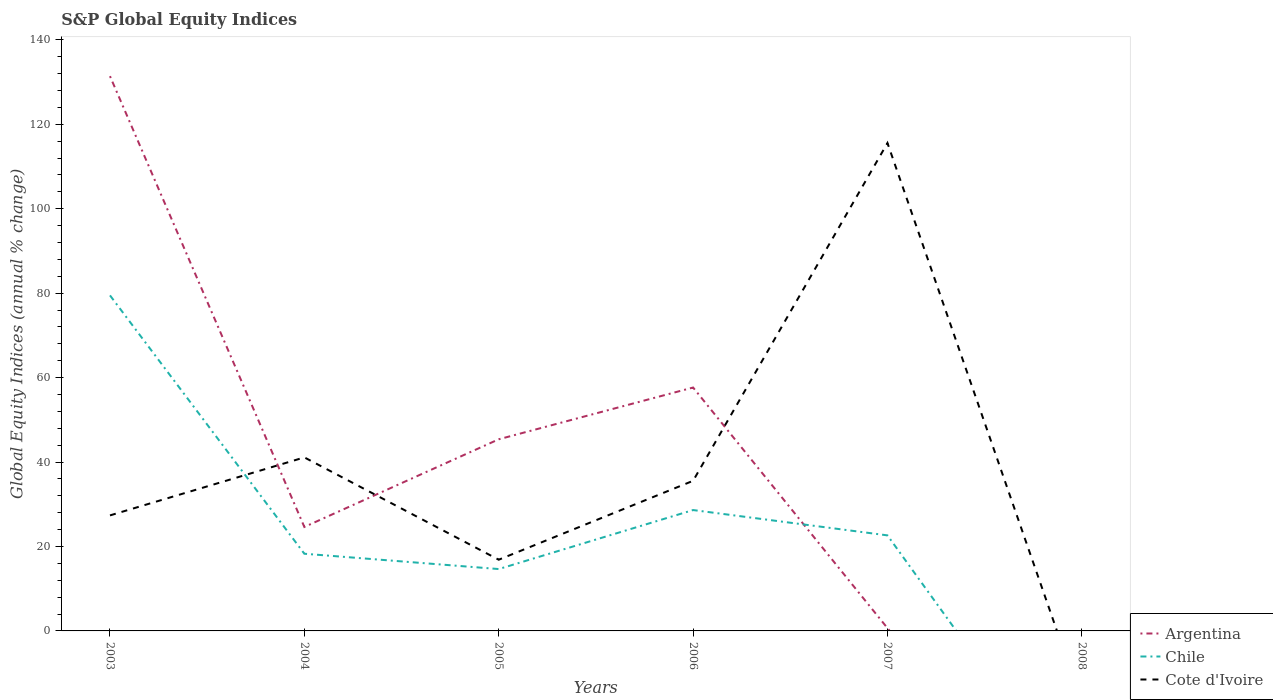What is the total global equity indices in Argentina in the graph?
Give a very brief answer. 23.95. What is the difference between the highest and the second highest global equity indices in Chile?
Provide a succinct answer. 79.47. What is the difference between the highest and the lowest global equity indices in Chile?
Your answer should be compact. 2. How many years are there in the graph?
Your response must be concise. 6. Are the values on the major ticks of Y-axis written in scientific E-notation?
Provide a short and direct response. No. How many legend labels are there?
Make the answer very short. 3. What is the title of the graph?
Offer a very short reply. S&P Global Equity Indices. Does "Sao Tome and Principe" appear as one of the legend labels in the graph?
Your answer should be very brief. No. What is the label or title of the Y-axis?
Your response must be concise. Global Equity Indices (annual % change). What is the Global Equity Indices (annual % change) of Argentina in 2003?
Provide a short and direct response. 131.39. What is the Global Equity Indices (annual % change) of Chile in 2003?
Ensure brevity in your answer.  79.47. What is the Global Equity Indices (annual % change) in Cote d'Ivoire in 2003?
Give a very brief answer. 27.36. What is the Global Equity Indices (annual % change) of Argentina in 2004?
Offer a very short reply. 24.62. What is the Global Equity Indices (annual % change) in Chile in 2004?
Your response must be concise. 18.28. What is the Global Equity Indices (annual % change) of Cote d'Ivoire in 2004?
Keep it short and to the point. 41.1. What is the Global Equity Indices (annual % change) of Argentina in 2005?
Keep it short and to the point. 45.39. What is the Global Equity Indices (annual % change) of Chile in 2005?
Ensure brevity in your answer.  14.65. What is the Global Equity Indices (annual % change) in Cote d'Ivoire in 2005?
Give a very brief answer. 16.87. What is the Global Equity Indices (annual % change) in Argentina in 2006?
Keep it short and to the point. 57.65. What is the Global Equity Indices (annual % change) of Chile in 2006?
Provide a short and direct response. 28.63. What is the Global Equity Indices (annual % change) of Cote d'Ivoire in 2006?
Ensure brevity in your answer.  35.55. What is the Global Equity Indices (annual % change) in Argentina in 2007?
Offer a terse response. 0.67. What is the Global Equity Indices (annual % change) of Chile in 2007?
Your response must be concise. 22.63. What is the Global Equity Indices (annual % change) of Cote d'Ivoire in 2007?
Keep it short and to the point. 115.56. Across all years, what is the maximum Global Equity Indices (annual % change) in Argentina?
Your response must be concise. 131.39. Across all years, what is the maximum Global Equity Indices (annual % change) of Chile?
Keep it short and to the point. 79.47. Across all years, what is the maximum Global Equity Indices (annual % change) in Cote d'Ivoire?
Offer a very short reply. 115.56. Across all years, what is the minimum Global Equity Indices (annual % change) of Chile?
Provide a succinct answer. 0. Across all years, what is the minimum Global Equity Indices (annual % change) in Cote d'Ivoire?
Give a very brief answer. 0. What is the total Global Equity Indices (annual % change) of Argentina in the graph?
Keep it short and to the point. 259.71. What is the total Global Equity Indices (annual % change) in Chile in the graph?
Make the answer very short. 163.66. What is the total Global Equity Indices (annual % change) in Cote d'Ivoire in the graph?
Ensure brevity in your answer.  236.44. What is the difference between the Global Equity Indices (annual % change) in Argentina in 2003 and that in 2004?
Make the answer very short. 106.77. What is the difference between the Global Equity Indices (annual % change) of Chile in 2003 and that in 2004?
Your answer should be very brief. 61.19. What is the difference between the Global Equity Indices (annual % change) of Cote d'Ivoire in 2003 and that in 2004?
Give a very brief answer. -13.74. What is the difference between the Global Equity Indices (annual % change) in Argentina in 2003 and that in 2005?
Make the answer very short. 86. What is the difference between the Global Equity Indices (annual % change) in Chile in 2003 and that in 2005?
Your answer should be compact. 64.82. What is the difference between the Global Equity Indices (annual % change) of Cote d'Ivoire in 2003 and that in 2005?
Your answer should be very brief. 10.49. What is the difference between the Global Equity Indices (annual % change) in Argentina in 2003 and that in 2006?
Give a very brief answer. 73.74. What is the difference between the Global Equity Indices (annual % change) in Chile in 2003 and that in 2006?
Your answer should be compact. 50.84. What is the difference between the Global Equity Indices (annual % change) of Cote d'Ivoire in 2003 and that in 2006?
Keep it short and to the point. -8.19. What is the difference between the Global Equity Indices (annual % change) in Argentina in 2003 and that in 2007?
Your response must be concise. 130.72. What is the difference between the Global Equity Indices (annual % change) of Chile in 2003 and that in 2007?
Provide a succinct answer. 56.84. What is the difference between the Global Equity Indices (annual % change) in Cote d'Ivoire in 2003 and that in 2007?
Offer a very short reply. -88.2. What is the difference between the Global Equity Indices (annual % change) of Argentina in 2004 and that in 2005?
Your response must be concise. -20.77. What is the difference between the Global Equity Indices (annual % change) in Chile in 2004 and that in 2005?
Your answer should be very brief. 3.63. What is the difference between the Global Equity Indices (annual % change) in Cote d'Ivoire in 2004 and that in 2005?
Your response must be concise. 24.23. What is the difference between the Global Equity Indices (annual % change) of Argentina in 2004 and that in 2006?
Your response must be concise. -33.03. What is the difference between the Global Equity Indices (annual % change) in Chile in 2004 and that in 2006?
Offer a very short reply. -10.35. What is the difference between the Global Equity Indices (annual % change) in Cote d'Ivoire in 2004 and that in 2006?
Make the answer very short. 5.55. What is the difference between the Global Equity Indices (annual % change) in Argentina in 2004 and that in 2007?
Offer a terse response. 23.95. What is the difference between the Global Equity Indices (annual % change) in Chile in 2004 and that in 2007?
Make the answer very short. -4.35. What is the difference between the Global Equity Indices (annual % change) in Cote d'Ivoire in 2004 and that in 2007?
Provide a short and direct response. -74.46. What is the difference between the Global Equity Indices (annual % change) of Argentina in 2005 and that in 2006?
Keep it short and to the point. -12.26. What is the difference between the Global Equity Indices (annual % change) of Chile in 2005 and that in 2006?
Make the answer very short. -13.98. What is the difference between the Global Equity Indices (annual % change) in Cote d'Ivoire in 2005 and that in 2006?
Your answer should be compact. -18.69. What is the difference between the Global Equity Indices (annual % change) of Argentina in 2005 and that in 2007?
Make the answer very short. 44.72. What is the difference between the Global Equity Indices (annual % change) of Chile in 2005 and that in 2007?
Provide a succinct answer. -7.98. What is the difference between the Global Equity Indices (annual % change) of Cote d'Ivoire in 2005 and that in 2007?
Provide a short and direct response. -98.69. What is the difference between the Global Equity Indices (annual % change) in Argentina in 2006 and that in 2007?
Provide a short and direct response. 56.98. What is the difference between the Global Equity Indices (annual % change) of Chile in 2006 and that in 2007?
Your answer should be compact. 6. What is the difference between the Global Equity Indices (annual % change) in Cote d'Ivoire in 2006 and that in 2007?
Keep it short and to the point. -80. What is the difference between the Global Equity Indices (annual % change) of Argentina in 2003 and the Global Equity Indices (annual % change) of Chile in 2004?
Ensure brevity in your answer.  113.11. What is the difference between the Global Equity Indices (annual % change) in Argentina in 2003 and the Global Equity Indices (annual % change) in Cote d'Ivoire in 2004?
Your answer should be compact. 90.29. What is the difference between the Global Equity Indices (annual % change) in Chile in 2003 and the Global Equity Indices (annual % change) in Cote d'Ivoire in 2004?
Your response must be concise. 38.37. What is the difference between the Global Equity Indices (annual % change) of Argentina in 2003 and the Global Equity Indices (annual % change) of Chile in 2005?
Ensure brevity in your answer.  116.74. What is the difference between the Global Equity Indices (annual % change) of Argentina in 2003 and the Global Equity Indices (annual % change) of Cote d'Ivoire in 2005?
Your answer should be very brief. 114.52. What is the difference between the Global Equity Indices (annual % change) of Chile in 2003 and the Global Equity Indices (annual % change) of Cote d'Ivoire in 2005?
Provide a short and direct response. 62.6. What is the difference between the Global Equity Indices (annual % change) of Argentina in 2003 and the Global Equity Indices (annual % change) of Chile in 2006?
Your response must be concise. 102.76. What is the difference between the Global Equity Indices (annual % change) in Argentina in 2003 and the Global Equity Indices (annual % change) in Cote d'Ivoire in 2006?
Keep it short and to the point. 95.84. What is the difference between the Global Equity Indices (annual % change) of Chile in 2003 and the Global Equity Indices (annual % change) of Cote d'Ivoire in 2006?
Offer a very short reply. 43.92. What is the difference between the Global Equity Indices (annual % change) of Argentina in 2003 and the Global Equity Indices (annual % change) of Chile in 2007?
Give a very brief answer. 108.76. What is the difference between the Global Equity Indices (annual % change) in Argentina in 2003 and the Global Equity Indices (annual % change) in Cote d'Ivoire in 2007?
Make the answer very short. 15.83. What is the difference between the Global Equity Indices (annual % change) in Chile in 2003 and the Global Equity Indices (annual % change) in Cote d'Ivoire in 2007?
Provide a succinct answer. -36.09. What is the difference between the Global Equity Indices (annual % change) in Argentina in 2004 and the Global Equity Indices (annual % change) in Chile in 2005?
Your answer should be compact. 9.97. What is the difference between the Global Equity Indices (annual % change) of Argentina in 2004 and the Global Equity Indices (annual % change) of Cote d'Ivoire in 2005?
Your answer should be very brief. 7.75. What is the difference between the Global Equity Indices (annual % change) in Chile in 2004 and the Global Equity Indices (annual % change) in Cote d'Ivoire in 2005?
Offer a very short reply. 1.41. What is the difference between the Global Equity Indices (annual % change) of Argentina in 2004 and the Global Equity Indices (annual % change) of Chile in 2006?
Keep it short and to the point. -4.01. What is the difference between the Global Equity Indices (annual % change) of Argentina in 2004 and the Global Equity Indices (annual % change) of Cote d'Ivoire in 2006?
Keep it short and to the point. -10.93. What is the difference between the Global Equity Indices (annual % change) of Chile in 2004 and the Global Equity Indices (annual % change) of Cote d'Ivoire in 2006?
Your response must be concise. -17.27. What is the difference between the Global Equity Indices (annual % change) in Argentina in 2004 and the Global Equity Indices (annual % change) in Chile in 2007?
Provide a short and direct response. 1.99. What is the difference between the Global Equity Indices (annual % change) of Argentina in 2004 and the Global Equity Indices (annual % change) of Cote d'Ivoire in 2007?
Make the answer very short. -90.94. What is the difference between the Global Equity Indices (annual % change) of Chile in 2004 and the Global Equity Indices (annual % change) of Cote d'Ivoire in 2007?
Provide a short and direct response. -97.28. What is the difference between the Global Equity Indices (annual % change) in Argentina in 2005 and the Global Equity Indices (annual % change) in Chile in 2006?
Give a very brief answer. 16.76. What is the difference between the Global Equity Indices (annual % change) of Argentina in 2005 and the Global Equity Indices (annual % change) of Cote d'Ivoire in 2006?
Offer a very short reply. 9.83. What is the difference between the Global Equity Indices (annual % change) in Chile in 2005 and the Global Equity Indices (annual % change) in Cote d'Ivoire in 2006?
Give a very brief answer. -20.9. What is the difference between the Global Equity Indices (annual % change) in Argentina in 2005 and the Global Equity Indices (annual % change) in Chile in 2007?
Your response must be concise. 22.76. What is the difference between the Global Equity Indices (annual % change) in Argentina in 2005 and the Global Equity Indices (annual % change) in Cote d'Ivoire in 2007?
Offer a terse response. -70.17. What is the difference between the Global Equity Indices (annual % change) in Chile in 2005 and the Global Equity Indices (annual % change) in Cote d'Ivoire in 2007?
Offer a very short reply. -100.9. What is the difference between the Global Equity Indices (annual % change) in Argentina in 2006 and the Global Equity Indices (annual % change) in Chile in 2007?
Provide a short and direct response. 35.02. What is the difference between the Global Equity Indices (annual % change) in Argentina in 2006 and the Global Equity Indices (annual % change) in Cote d'Ivoire in 2007?
Your answer should be very brief. -57.91. What is the difference between the Global Equity Indices (annual % change) of Chile in 2006 and the Global Equity Indices (annual % change) of Cote d'Ivoire in 2007?
Ensure brevity in your answer.  -86.93. What is the average Global Equity Indices (annual % change) of Argentina per year?
Your answer should be very brief. 43.29. What is the average Global Equity Indices (annual % change) of Chile per year?
Your answer should be compact. 27.28. What is the average Global Equity Indices (annual % change) of Cote d'Ivoire per year?
Make the answer very short. 39.41. In the year 2003, what is the difference between the Global Equity Indices (annual % change) of Argentina and Global Equity Indices (annual % change) of Chile?
Ensure brevity in your answer.  51.92. In the year 2003, what is the difference between the Global Equity Indices (annual % change) in Argentina and Global Equity Indices (annual % change) in Cote d'Ivoire?
Offer a very short reply. 104.03. In the year 2003, what is the difference between the Global Equity Indices (annual % change) in Chile and Global Equity Indices (annual % change) in Cote d'Ivoire?
Your answer should be very brief. 52.11. In the year 2004, what is the difference between the Global Equity Indices (annual % change) in Argentina and Global Equity Indices (annual % change) in Chile?
Your answer should be compact. 6.34. In the year 2004, what is the difference between the Global Equity Indices (annual % change) in Argentina and Global Equity Indices (annual % change) in Cote d'Ivoire?
Provide a short and direct response. -16.48. In the year 2004, what is the difference between the Global Equity Indices (annual % change) of Chile and Global Equity Indices (annual % change) of Cote d'Ivoire?
Provide a succinct answer. -22.82. In the year 2005, what is the difference between the Global Equity Indices (annual % change) of Argentina and Global Equity Indices (annual % change) of Chile?
Provide a succinct answer. 30.74. In the year 2005, what is the difference between the Global Equity Indices (annual % change) in Argentina and Global Equity Indices (annual % change) in Cote d'Ivoire?
Offer a very short reply. 28.52. In the year 2005, what is the difference between the Global Equity Indices (annual % change) of Chile and Global Equity Indices (annual % change) of Cote d'Ivoire?
Your answer should be very brief. -2.21. In the year 2006, what is the difference between the Global Equity Indices (annual % change) in Argentina and Global Equity Indices (annual % change) in Chile?
Offer a terse response. 29.02. In the year 2006, what is the difference between the Global Equity Indices (annual % change) of Argentina and Global Equity Indices (annual % change) of Cote d'Ivoire?
Your answer should be very brief. 22.09. In the year 2006, what is the difference between the Global Equity Indices (annual % change) in Chile and Global Equity Indices (annual % change) in Cote d'Ivoire?
Provide a succinct answer. -6.93. In the year 2007, what is the difference between the Global Equity Indices (annual % change) in Argentina and Global Equity Indices (annual % change) in Chile?
Keep it short and to the point. -21.96. In the year 2007, what is the difference between the Global Equity Indices (annual % change) in Argentina and Global Equity Indices (annual % change) in Cote d'Ivoire?
Offer a very short reply. -114.89. In the year 2007, what is the difference between the Global Equity Indices (annual % change) in Chile and Global Equity Indices (annual % change) in Cote d'Ivoire?
Offer a very short reply. -92.93. What is the ratio of the Global Equity Indices (annual % change) in Argentina in 2003 to that in 2004?
Provide a short and direct response. 5.34. What is the ratio of the Global Equity Indices (annual % change) of Chile in 2003 to that in 2004?
Ensure brevity in your answer.  4.35. What is the ratio of the Global Equity Indices (annual % change) in Cote d'Ivoire in 2003 to that in 2004?
Offer a very short reply. 0.67. What is the ratio of the Global Equity Indices (annual % change) of Argentina in 2003 to that in 2005?
Make the answer very short. 2.89. What is the ratio of the Global Equity Indices (annual % change) in Chile in 2003 to that in 2005?
Provide a succinct answer. 5.42. What is the ratio of the Global Equity Indices (annual % change) of Cote d'Ivoire in 2003 to that in 2005?
Provide a short and direct response. 1.62. What is the ratio of the Global Equity Indices (annual % change) of Argentina in 2003 to that in 2006?
Provide a short and direct response. 2.28. What is the ratio of the Global Equity Indices (annual % change) in Chile in 2003 to that in 2006?
Provide a short and direct response. 2.78. What is the ratio of the Global Equity Indices (annual % change) in Cote d'Ivoire in 2003 to that in 2006?
Offer a very short reply. 0.77. What is the ratio of the Global Equity Indices (annual % change) in Argentina in 2003 to that in 2007?
Offer a very short reply. 196.39. What is the ratio of the Global Equity Indices (annual % change) of Chile in 2003 to that in 2007?
Provide a short and direct response. 3.51. What is the ratio of the Global Equity Indices (annual % change) in Cote d'Ivoire in 2003 to that in 2007?
Your answer should be compact. 0.24. What is the ratio of the Global Equity Indices (annual % change) of Argentina in 2004 to that in 2005?
Make the answer very short. 0.54. What is the ratio of the Global Equity Indices (annual % change) in Chile in 2004 to that in 2005?
Your response must be concise. 1.25. What is the ratio of the Global Equity Indices (annual % change) in Cote d'Ivoire in 2004 to that in 2005?
Your answer should be compact. 2.44. What is the ratio of the Global Equity Indices (annual % change) of Argentina in 2004 to that in 2006?
Give a very brief answer. 0.43. What is the ratio of the Global Equity Indices (annual % change) of Chile in 2004 to that in 2006?
Your answer should be very brief. 0.64. What is the ratio of the Global Equity Indices (annual % change) of Cote d'Ivoire in 2004 to that in 2006?
Keep it short and to the point. 1.16. What is the ratio of the Global Equity Indices (annual % change) in Argentina in 2004 to that in 2007?
Your answer should be compact. 36.8. What is the ratio of the Global Equity Indices (annual % change) of Chile in 2004 to that in 2007?
Offer a terse response. 0.81. What is the ratio of the Global Equity Indices (annual % change) in Cote d'Ivoire in 2004 to that in 2007?
Ensure brevity in your answer.  0.36. What is the ratio of the Global Equity Indices (annual % change) in Argentina in 2005 to that in 2006?
Offer a terse response. 0.79. What is the ratio of the Global Equity Indices (annual % change) of Chile in 2005 to that in 2006?
Offer a terse response. 0.51. What is the ratio of the Global Equity Indices (annual % change) in Cote d'Ivoire in 2005 to that in 2006?
Make the answer very short. 0.47. What is the ratio of the Global Equity Indices (annual % change) of Argentina in 2005 to that in 2007?
Provide a short and direct response. 67.84. What is the ratio of the Global Equity Indices (annual % change) of Chile in 2005 to that in 2007?
Offer a very short reply. 0.65. What is the ratio of the Global Equity Indices (annual % change) in Cote d'Ivoire in 2005 to that in 2007?
Your answer should be compact. 0.15. What is the ratio of the Global Equity Indices (annual % change) in Argentina in 2006 to that in 2007?
Give a very brief answer. 86.17. What is the ratio of the Global Equity Indices (annual % change) of Chile in 2006 to that in 2007?
Provide a succinct answer. 1.26. What is the ratio of the Global Equity Indices (annual % change) in Cote d'Ivoire in 2006 to that in 2007?
Keep it short and to the point. 0.31. What is the difference between the highest and the second highest Global Equity Indices (annual % change) of Argentina?
Your answer should be very brief. 73.74. What is the difference between the highest and the second highest Global Equity Indices (annual % change) of Chile?
Your answer should be compact. 50.84. What is the difference between the highest and the second highest Global Equity Indices (annual % change) in Cote d'Ivoire?
Your answer should be compact. 74.46. What is the difference between the highest and the lowest Global Equity Indices (annual % change) of Argentina?
Offer a terse response. 131.39. What is the difference between the highest and the lowest Global Equity Indices (annual % change) of Chile?
Provide a succinct answer. 79.47. What is the difference between the highest and the lowest Global Equity Indices (annual % change) in Cote d'Ivoire?
Offer a very short reply. 115.56. 